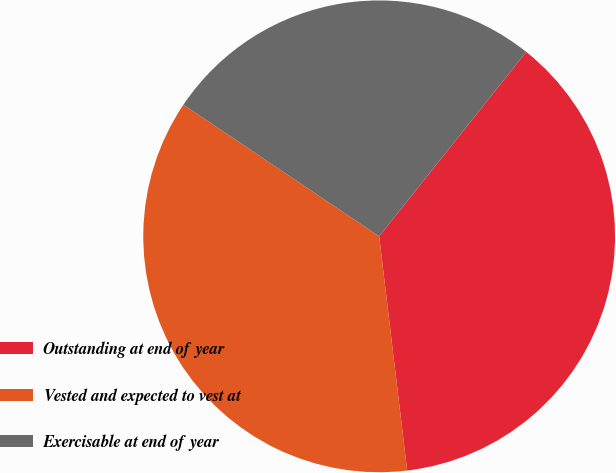Convert chart to OTSL. <chart><loc_0><loc_0><loc_500><loc_500><pie_chart><fcel>Outstanding at end of year<fcel>Vested and expected to vest at<fcel>Exercisable at end of year<nl><fcel>37.4%<fcel>36.32%<fcel>26.29%<nl></chart> 